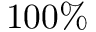Convert formula to latex. <formula><loc_0><loc_0><loc_500><loc_500>1 0 0 \%</formula> 